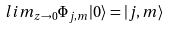<formula> <loc_0><loc_0><loc_500><loc_500>l i m _ { z \rightarrow 0 } \Phi _ { j , m } | 0 \rangle = | j , m \rangle</formula> 